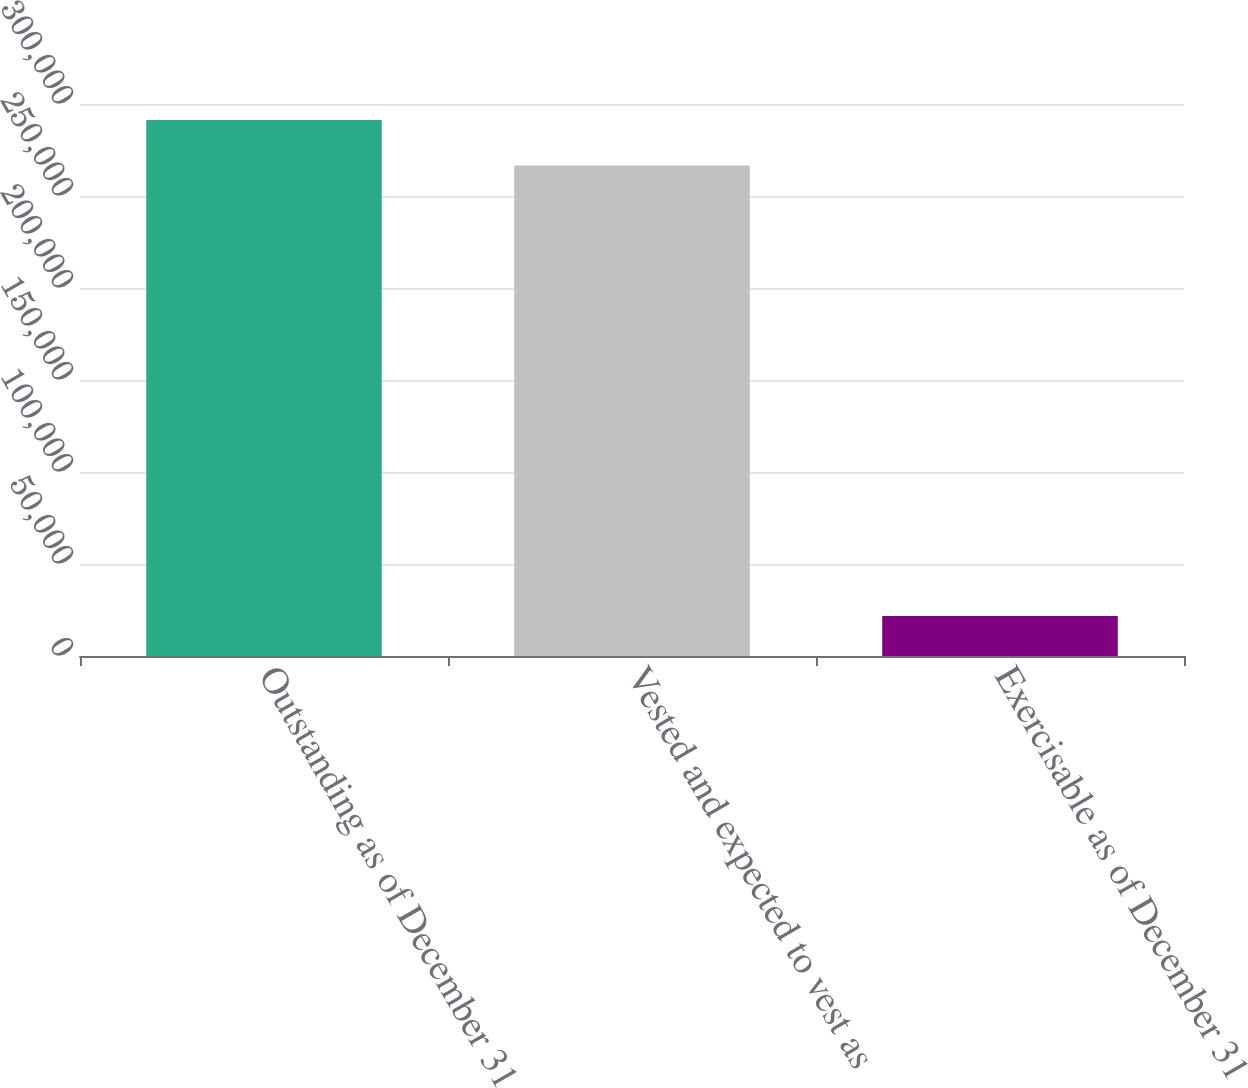Convert chart. <chart><loc_0><loc_0><loc_500><loc_500><bar_chart><fcel>Outstanding as of December 31<fcel>Vested and expected to vest as<fcel>Exercisable as of December 31<nl><fcel>291280<fcel>266611<fcel>21701<nl></chart> 